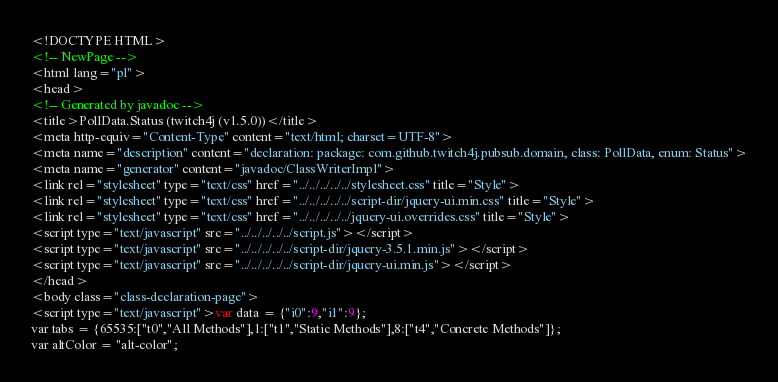<code> <loc_0><loc_0><loc_500><loc_500><_HTML_><!DOCTYPE HTML>
<!-- NewPage -->
<html lang="pl">
<head>
<!-- Generated by javadoc -->
<title>PollData.Status (twitch4j (v1.5.0))</title>
<meta http-equiv="Content-Type" content="text/html; charset=UTF-8">
<meta name="description" content="declaration: package: com.github.twitch4j.pubsub.domain, class: PollData, enum: Status">
<meta name="generator" content="javadoc/ClassWriterImpl">
<link rel="stylesheet" type="text/css" href="../../../../../stylesheet.css" title="Style">
<link rel="stylesheet" type="text/css" href="../../../../../script-dir/jquery-ui.min.css" title="Style">
<link rel="stylesheet" type="text/css" href="../../../../../jquery-ui.overrides.css" title="Style">
<script type="text/javascript" src="../../../../../script.js"></script>
<script type="text/javascript" src="../../../../../script-dir/jquery-3.5.1.min.js"></script>
<script type="text/javascript" src="../../../../../script-dir/jquery-ui.min.js"></script>
</head>
<body class="class-declaration-page">
<script type="text/javascript">var data = {"i0":9,"i1":9};
var tabs = {65535:["t0","All Methods"],1:["t1","Static Methods"],8:["t4","Concrete Methods"]};
var altColor = "alt-color";</code> 